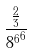Convert formula to latex. <formula><loc_0><loc_0><loc_500><loc_500>\frac { \frac { 2 } { 3 } } { { 8 ^ { 6 } } ^ { 6 } }</formula> 